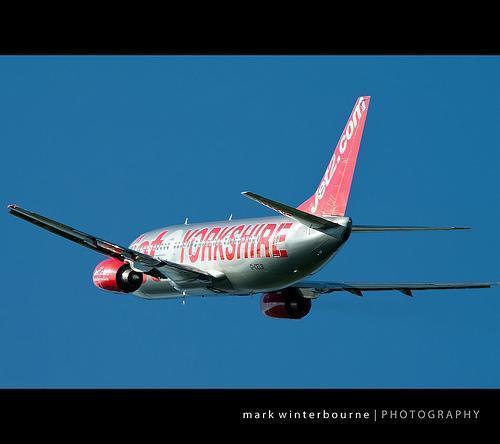How many engines are on the airplane?
Give a very brief answer. 2. 